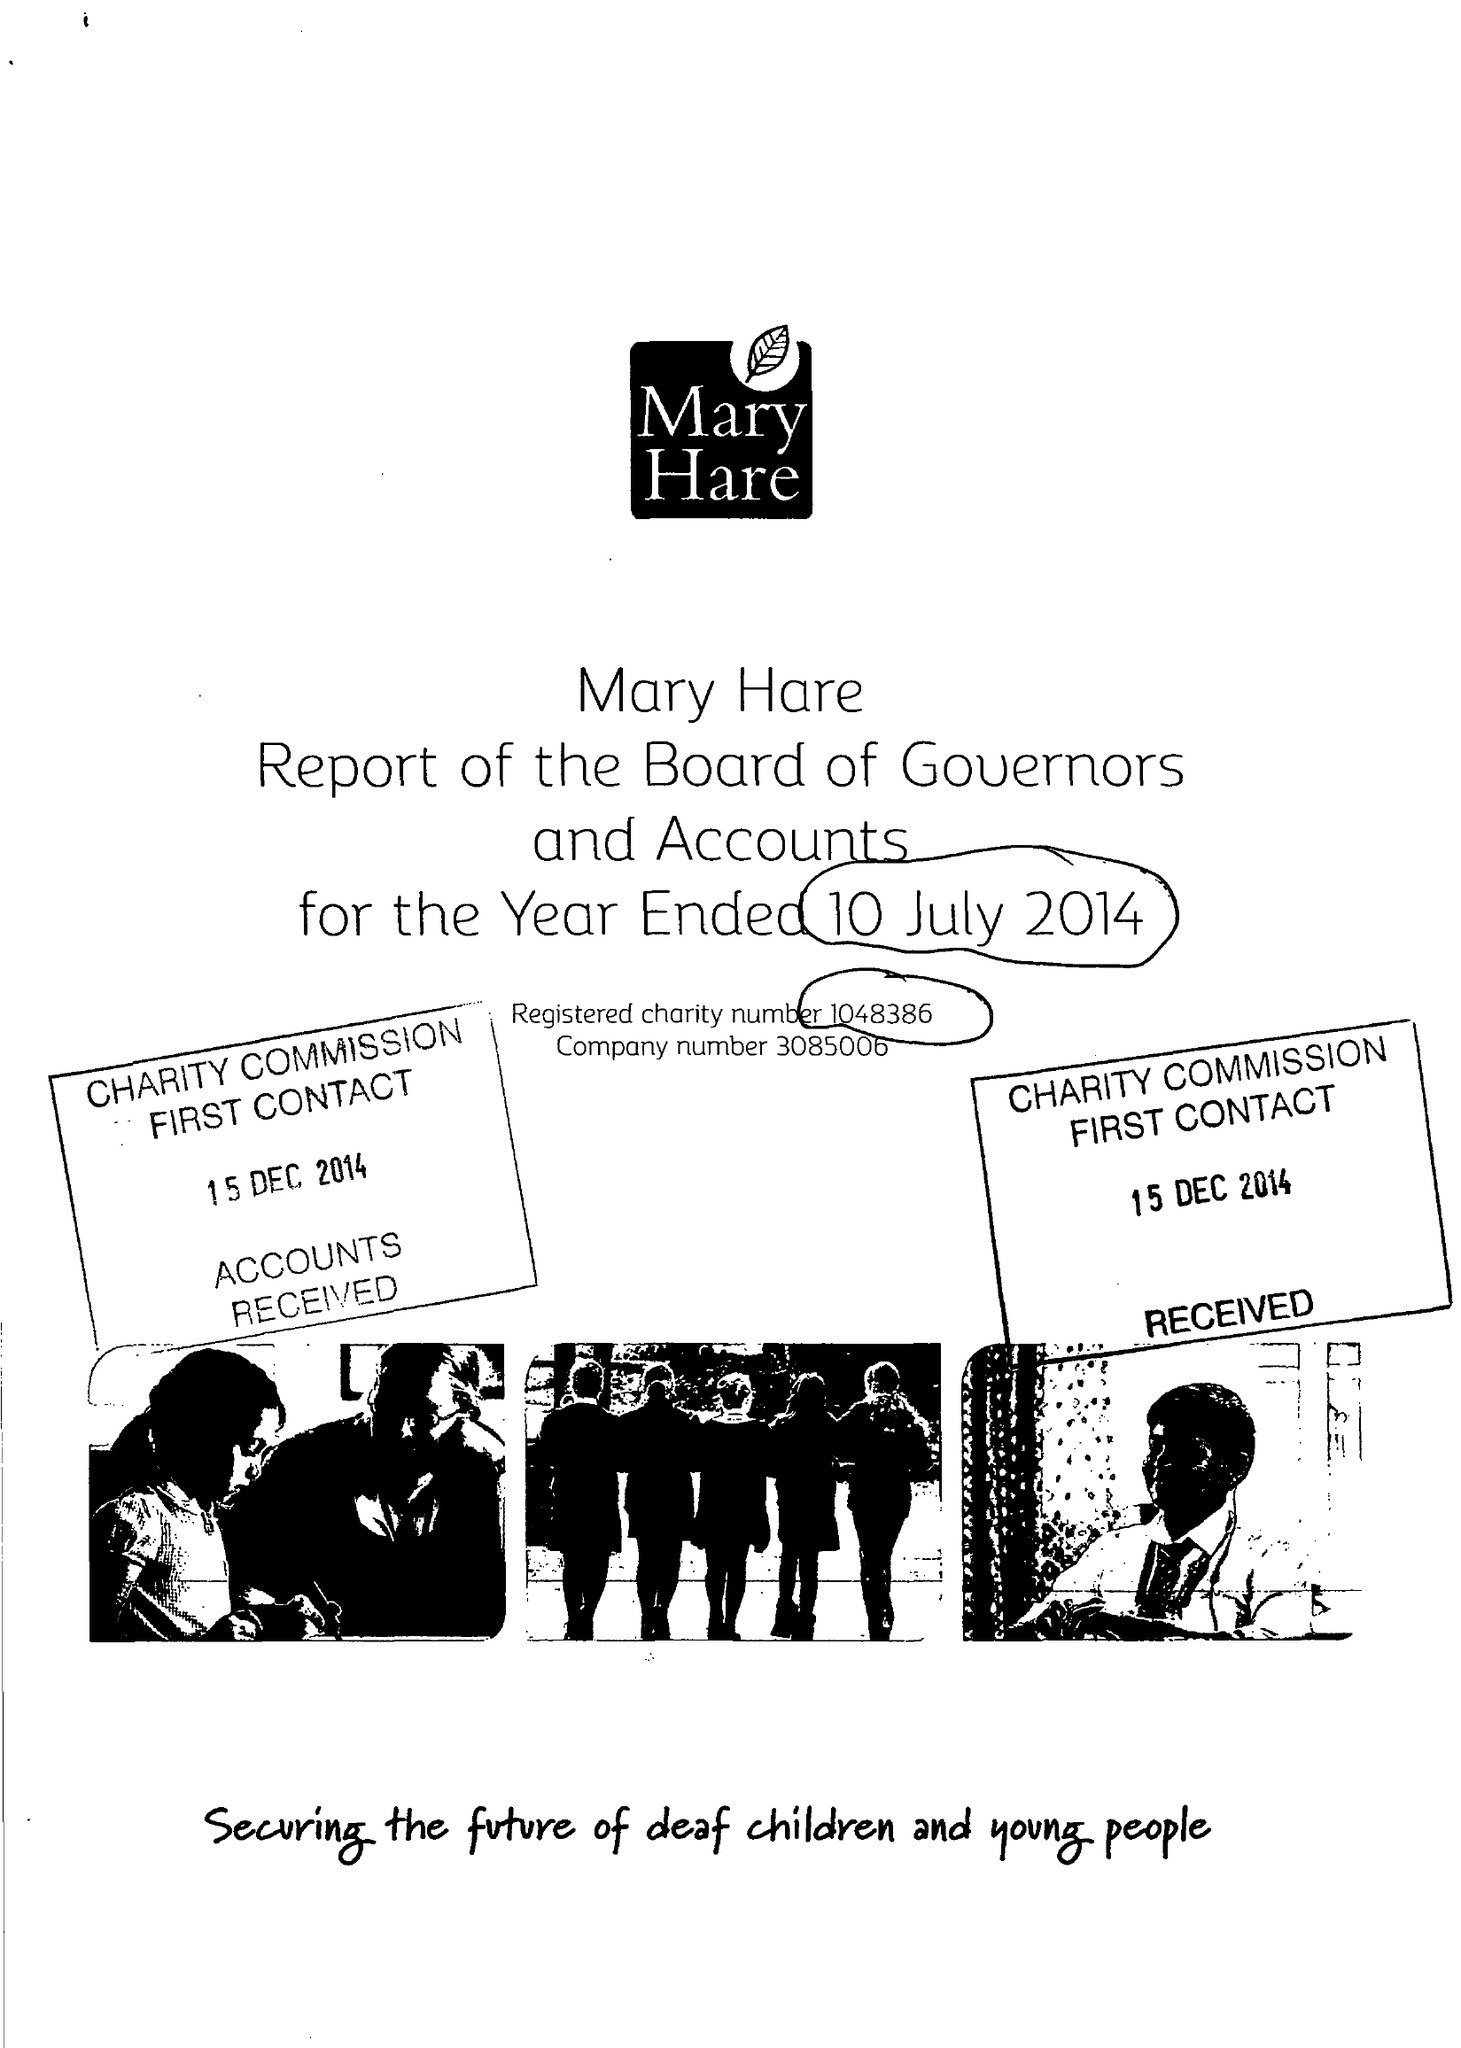What is the value for the report_date?
Answer the question using a single word or phrase. 2014-07-10 